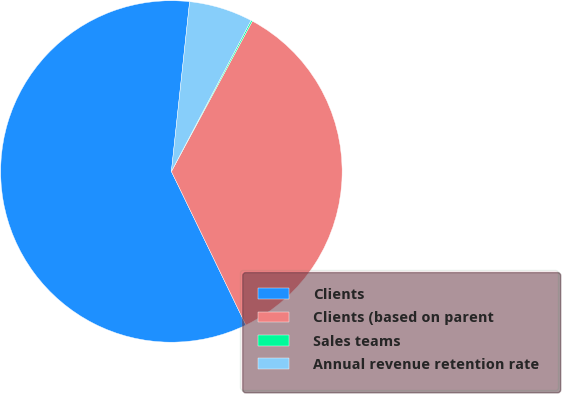Convert chart to OTSL. <chart><loc_0><loc_0><loc_500><loc_500><pie_chart><fcel>Clients<fcel>Clients (based on parent<fcel>Sales teams<fcel>Annual revenue retention rate<nl><fcel>58.89%<fcel>34.95%<fcel>0.14%<fcel>6.02%<nl></chart> 